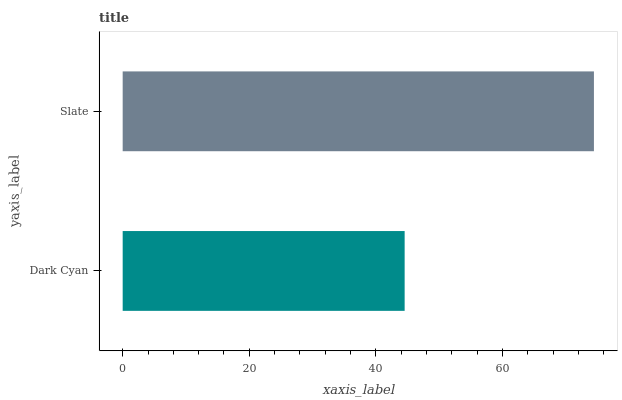Is Dark Cyan the minimum?
Answer yes or no. Yes. Is Slate the maximum?
Answer yes or no. Yes. Is Slate the minimum?
Answer yes or no. No. Is Slate greater than Dark Cyan?
Answer yes or no. Yes. Is Dark Cyan less than Slate?
Answer yes or no. Yes. Is Dark Cyan greater than Slate?
Answer yes or no. No. Is Slate less than Dark Cyan?
Answer yes or no. No. Is Slate the high median?
Answer yes or no. Yes. Is Dark Cyan the low median?
Answer yes or no. Yes. Is Dark Cyan the high median?
Answer yes or no. No. Is Slate the low median?
Answer yes or no. No. 